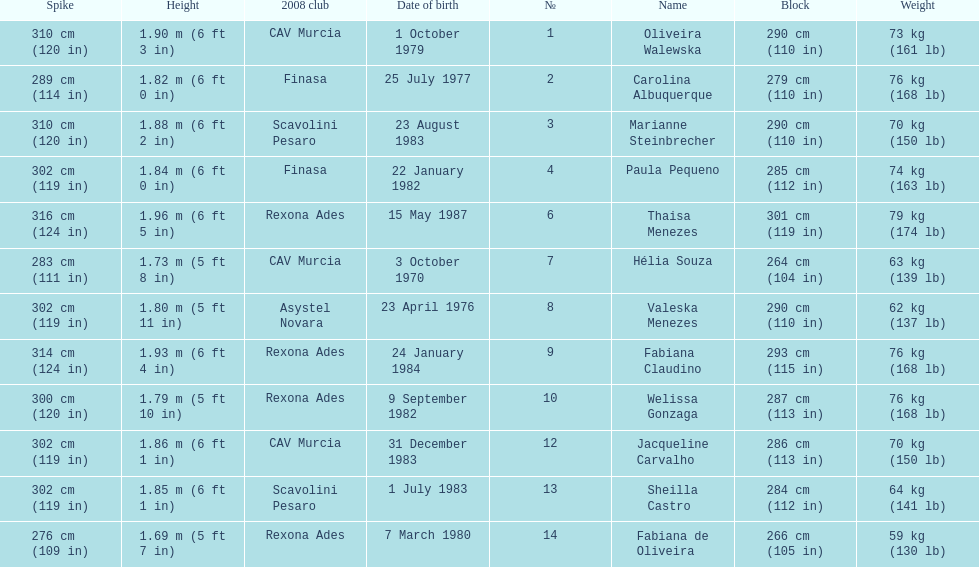Oliveira walewska has the same block as how many other players? 2. Parse the table in full. {'header': ['Spike', 'Height', '2008 club', 'Date of birth', '№', 'Name', 'Block', 'Weight'], 'rows': [['310\xa0cm (120\xa0in)', '1.90\xa0m (6\xa0ft 3\xa0in)', 'CAV Murcia', '1 October 1979', '1', 'Oliveira Walewska', '290\xa0cm (110\xa0in)', '73\xa0kg (161\xa0lb)'], ['289\xa0cm (114\xa0in)', '1.82\xa0m (6\xa0ft 0\xa0in)', 'Finasa', '25 July 1977', '2', 'Carolina Albuquerque', '279\xa0cm (110\xa0in)', '76\xa0kg (168\xa0lb)'], ['310\xa0cm (120\xa0in)', '1.88\xa0m (6\xa0ft 2\xa0in)', 'Scavolini Pesaro', '23 August 1983', '3', 'Marianne Steinbrecher', '290\xa0cm (110\xa0in)', '70\xa0kg (150\xa0lb)'], ['302\xa0cm (119\xa0in)', '1.84\xa0m (6\xa0ft 0\xa0in)', 'Finasa', '22 January 1982', '4', 'Paula Pequeno', '285\xa0cm (112\xa0in)', '74\xa0kg (163\xa0lb)'], ['316\xa0cm (124\xa0in)', '1.96\xa0m (6\xa0ft 5\xa0in)', 'Rexona Ades', '15 May 1987', '6', 'Thaisa Menezes', '301\xa0cm (119\xa0in)', '79\xa0kg (174\xa0lb)'], ['283\xa0cm (111\xa0in)', '1.73\xa0m (5\xa0ft 8\xa0in)', 'CAV Murcia', '3 October 1970', '7', 'Hélia Souza', '264\xa0cm (104\xa0in)', '63\xa0kg (139\xa0lb)'], ['302\xa0cm (119\xa0in)', '1.80\xa0m (5\xa0ft 11\xa0in)', 'Asystel Novara', '23 April 1976', '8', 'Valeska Menezes', '290\xa0cm (110\xa0in)', '62\xa0kg (137\xa0lb)'], ['314\xa0cm (124\xa0in)', '1.93\xa0m (6\xa0ft 4\xa0in)', 'Rexona Ades', '24 January 1984', '9', 'Fabiana Claudino', '293\xa0cm (115\xa0in)', '76\xa0kg (168\xa0lb)'], ['300\xa0cm (120\xa0in)', '1.79\xa0m (5\xa0ft 10\xa0in)', 'Rexona Ades', '9 September 1982', '10', 'Welissa Gonzaga', '287\xa0cm (113\xa0in)', '76\xa0kg (168\xa0lb)'], ['302\xa0cm (119\xa0in)', '1.86\xa0m (6\xa0ft 1\xa0in)', 'CAV Murcia', '31 December 1983', '12', 'Jacqueline Carvalho', '286\xa0cm (113\xa0in)', '70\xa0kg (150\xa0lb)'], ['302\xa0cm (119\xa0in)', '1.85\xa0m (6\xa0ft 1\xa0in)', 'Scavolini Pesaro', '1 July 1983', '13', 'Sheilla Castro', '284\xa0cm (112\xa0in)', '64\xa0kg (141\xa0lb)'], ['276\xa0cm (109\xa0in)', '1.69\xa0m (5\xa0ft 7\xa0in)', 'Rexona Ades', '7 March 1980', '14', 'Fabiana de Oliveira', '266\xa0cm (105\xa0in)', '59\xa0kg (130\xa0lb)']]} 